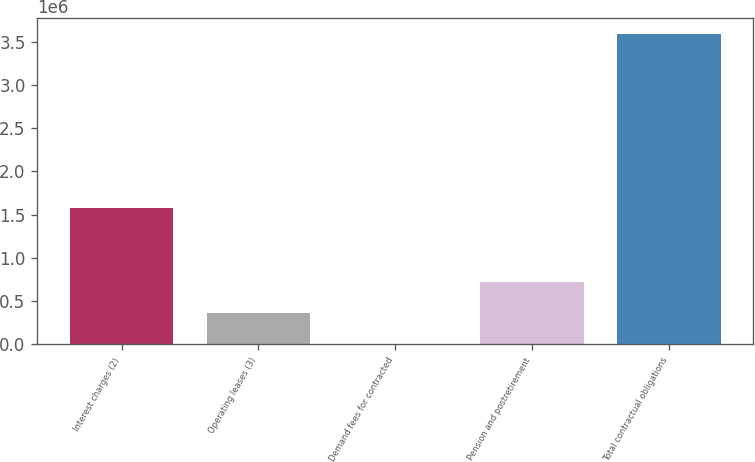<chart> <loc_0><loc_0><loc_500><loc_500><bar_chart><fcel>Interest charges (2)<fcel>Operating leases (3)<fcel>Demand fees for contracted<fcel>Pension and postretirement<fcel>Total contractual obligations<nl><fcel>1.57715e+06<fcel>360072<fcel>678<fcel>719466<fcel>3.59462e+06<nl></chart> 